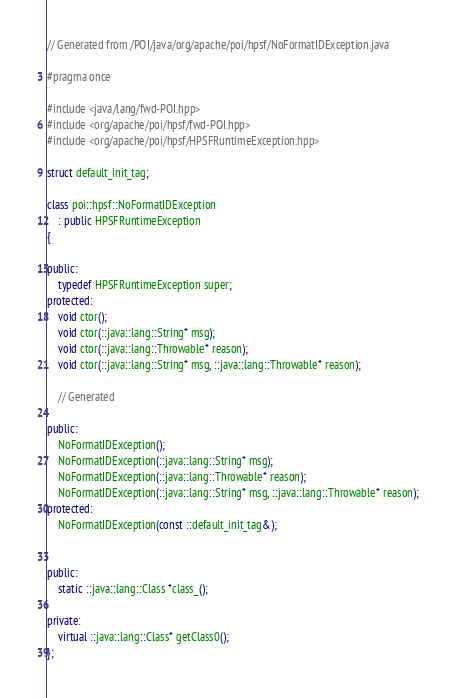Convert code to text. <code><loc_0><loc_0><loc_500><loc_500><_C++_>// Generated from /POI/java/org/apache/poi/hpsf/NoFormatIDException.java

#pragma once

#include <java/lang/fwd-POI.hpp>
#include <org/apache/poi/hpsf/fwd-POI.hpp>
#include <org/apache/poi/hpsf/HPSFRuntimeException.hpp>

struct default_init_tag;

class poi::hpsf::NoFormatIDException
    : public HPSFRuntimeException
{

public:
    typedef HPSFRuntimeException super;
protected:
    void ctor();
    void ctor(::java::lang::String* msg);
    void ctor(::java::lang::Throwable* reason);
    void ctor(::java::lang::String* msg, ::java::lang::Throwable* reason);

    // Generated

public:
    NoFormatIDException();
    NoFormatIDException(::java::lang::String* msg);
    NoFormatIDException(::java::lang::Throwable* reason);
    NoFormatIDException(::java::lang::String* msg, ::java::lang::Throwable* reason);
protected:
    NoFormatIDException(const ::default_init_tag&);


public:
    static ::java::lang::Class *class_();

private:
    virtual ::java::lang::Class* getClass0();
};
</code> 